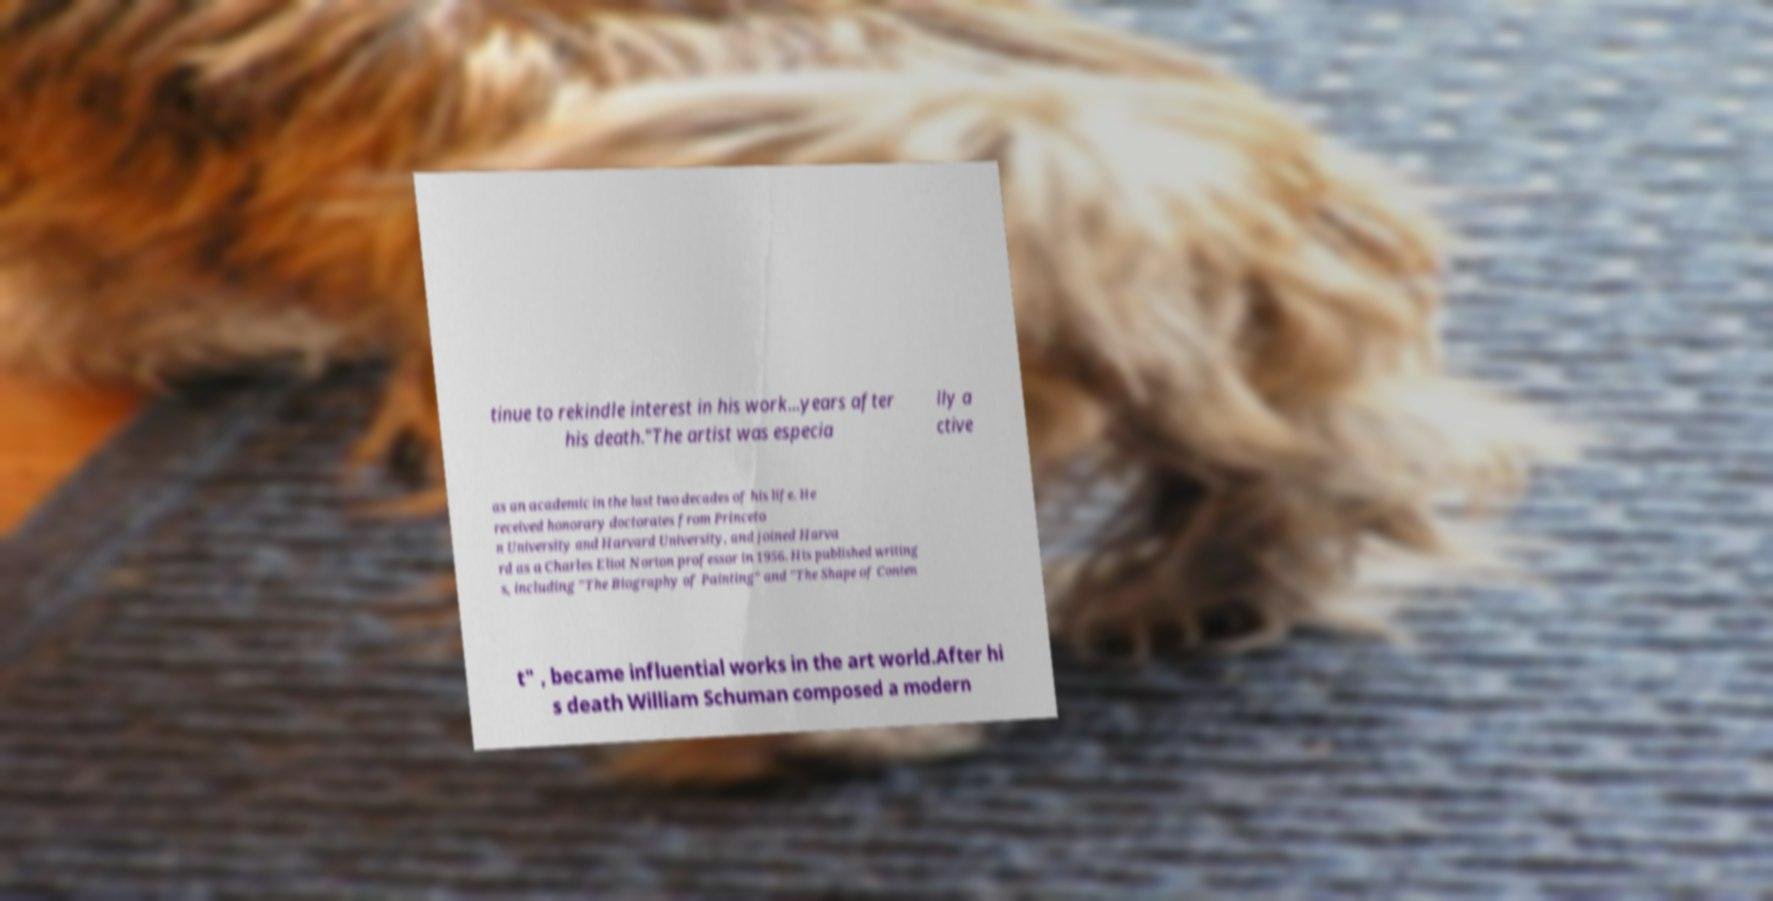What messages or text are displayed in this image? I need them in a readable, typed format. tinue to rekindle interest in his work...years after his death."The artist was especia lly a ctive as an academic in the last two decades of his life. He received honorary doctorates from Princeto n University and Harvard University, and joined Harva rd as a Charles Eliot Norton professor in 1956. His published writing s, including "The Biography of Painting" and "The Shape of Conten t" , became influential works in the art world.After hi s death William Schuman composed a modern 